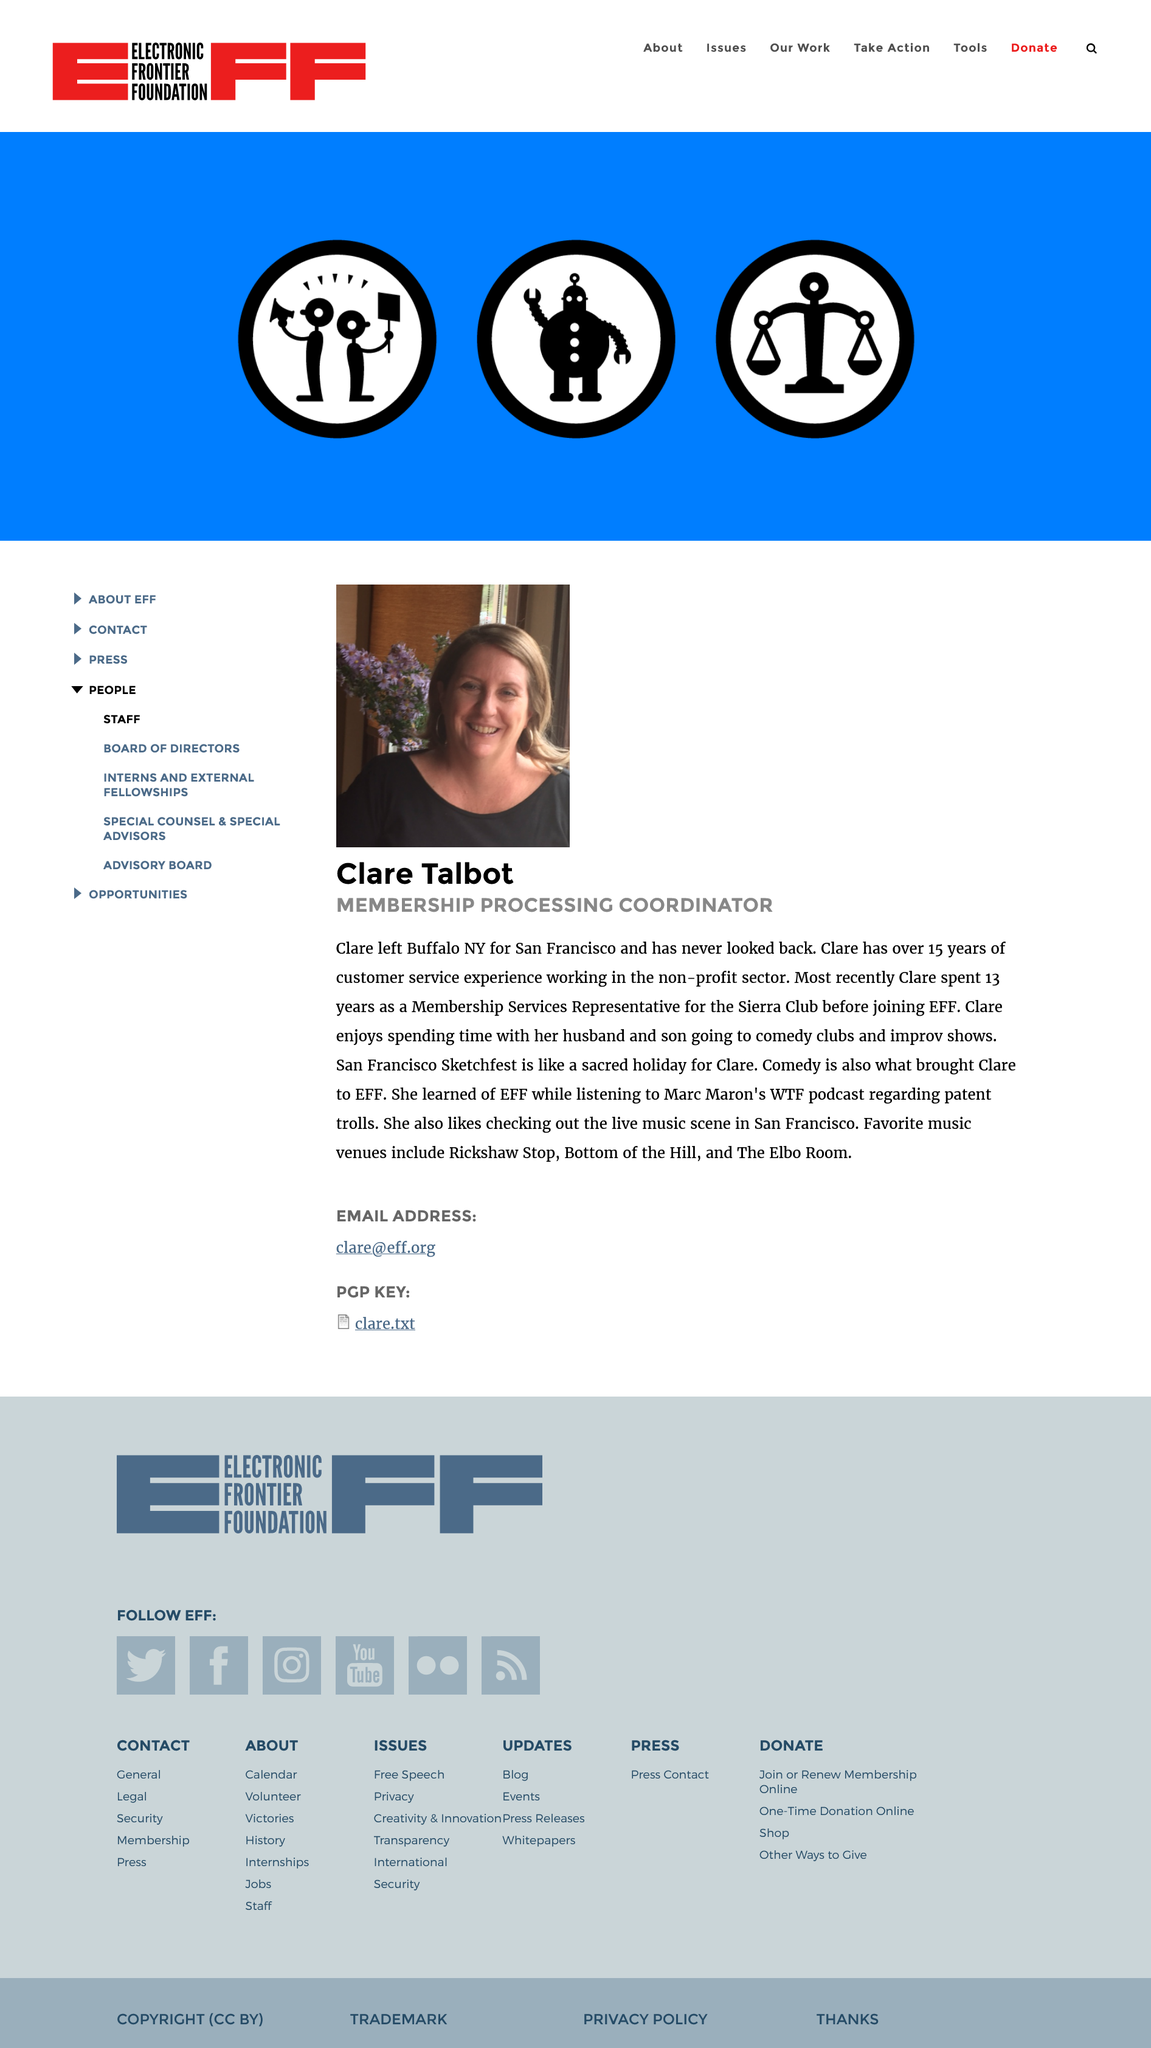Outline some significant characteristics in this image. Claire Talbot is the Membership Processing Coordinator for the Electronic Frontier Foundation (EFF). Claire Talbot enjoys frequenting Rickshaw Stop, Bottom of the Hill, and Elbo Room as her favourite music venues. Claire Talbot worked for the Sierra Club for 13 years before joining the EFF. During her tenure at the Sierra Club, she served as a member services representative. 